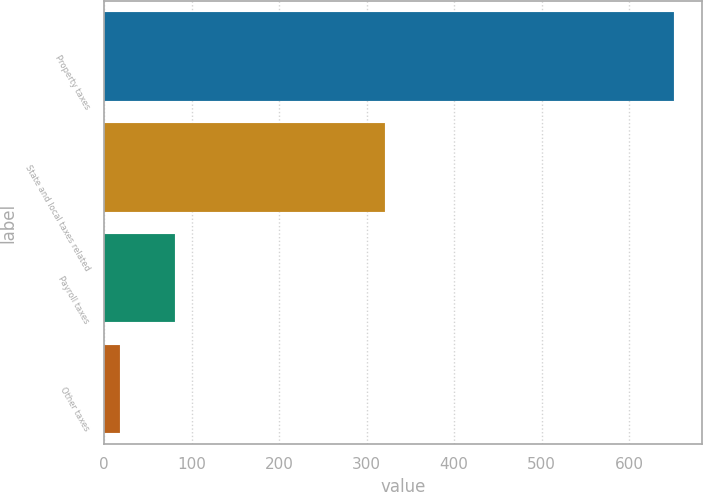Convert chart. <chart><loc_0><loc_0><loc_500><loc_500><bar_chart><fcel>Property taxes<fcel>State and local taxes related<fcel>Payroll taxes<fcel>Other taxes<nl><fcel>651<fcel>321<fcel>81.3<fcel>18<nl></chart> 